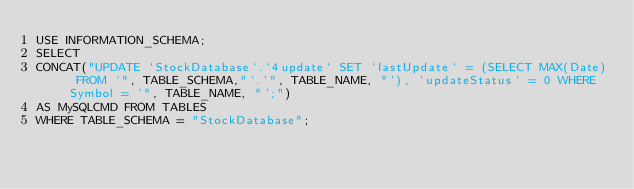<code> <loc_0><loc_0><loc_500><loc_500><_SQL_>USE INFORMATION_SCHEMA;
SELECT 
CONCAT("UPDATE `StockDatabase`.`4update` SET `lastUpdate` = (SELECT MAX(Date) FROM `", TABLE_SCHEMA,"`.`", TABLE_NAME, "`), `updateStatus` = 0 WHERE Symbol = '", TABLE_NAME, "';") 
AS MySQLCMD FROM TABLES 
WHERE TABLE_SCHEMA = "StockDatabase";</code> 